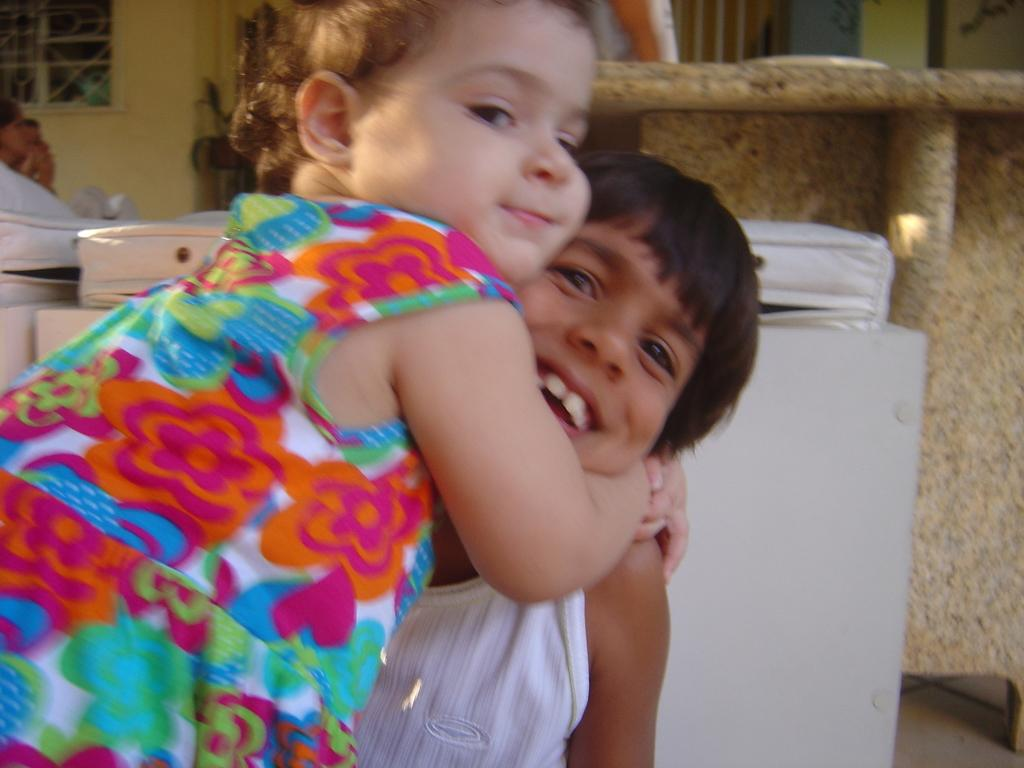How many kids are in the image? There are two kids in the center of the image. What can be seen in the background of the image? There is a wall and a window in the background of the image. What type of advertisement can be seen on the wall in the image? There is no advertisement visible on the wall in the image. Can you spot a rat in the image? There is no rat present in the image. 